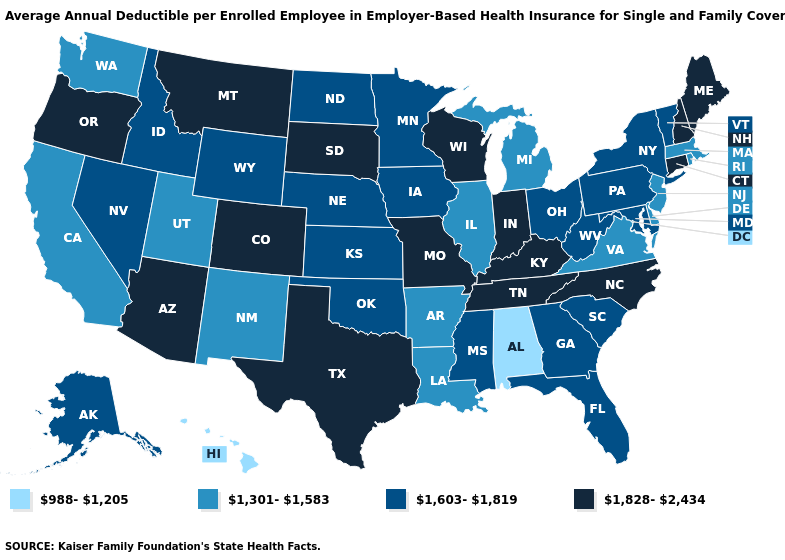Does Arizona have the highest value in the USA?
Give a very brief answer. Yes. Does South Dakota have a lower value than California?
Write a very short answer. No. What is the value of Texas?
Be succinct. 1,828-2,434. Name the states that have a value in the range 1,603-1,819?
Answer briefly. Alaska, Florida, Georgia, Idaho, Iowa, Kansas, Maryland, Minnesota, Mississippi, Nebraska, Nevada, New York, North Dakota, Ohio, Oklahoma, Pennsylvania, South Carolina, Vermont, West Virginia, Wyoming. Name the states that have a value in the range 1,828-2,434?
Answer briefly. Arizona, Colorado, Connecticut, Indiana, Kentucky, Maine, Missouri, Montana, New Hampshire, North Carolina, Oregon, South Dakota, Tennessee, Texas, Wisconsin. What is the value of Oklahoma?
Give a very brief answer. 1,603-1,819. What is the value of Massachusetts?
Quick response, please. 1,301-1,583. Does Texas have the highest value in the USA?
Concise answer only. Yes. What is the highest value in the West ?
Quick response, please. 1,828-2,434. Does the map have missing data?
Concise answer only. No. What is the lowest value in the South?
Short answer required. 988-1,205. What is the value of Virginia?
Be succinct. 1,301-1,583. Name the states that have a value in the range 1,828-2,434?
Answer briefly. Arizona, Colorado, Connecticut, Indiana, Kentucky, Maine, Missouri, Montana, New Hampshire, North Carolina, Oregon, South Dakota, Tennessee, Texas, Wisconsin. Which states have the lowest value in the USA?
Short answer required. Alabama, Hawaii. Name the states that have a value in the range 1,301-1,583?
Short answer required. Arkansas, California, Delaware, Illinois, Louisiana, Massachusetts, Michigan, New Jersey, New Mexico, Rhode Island, Utah, Virginia, Washington. 